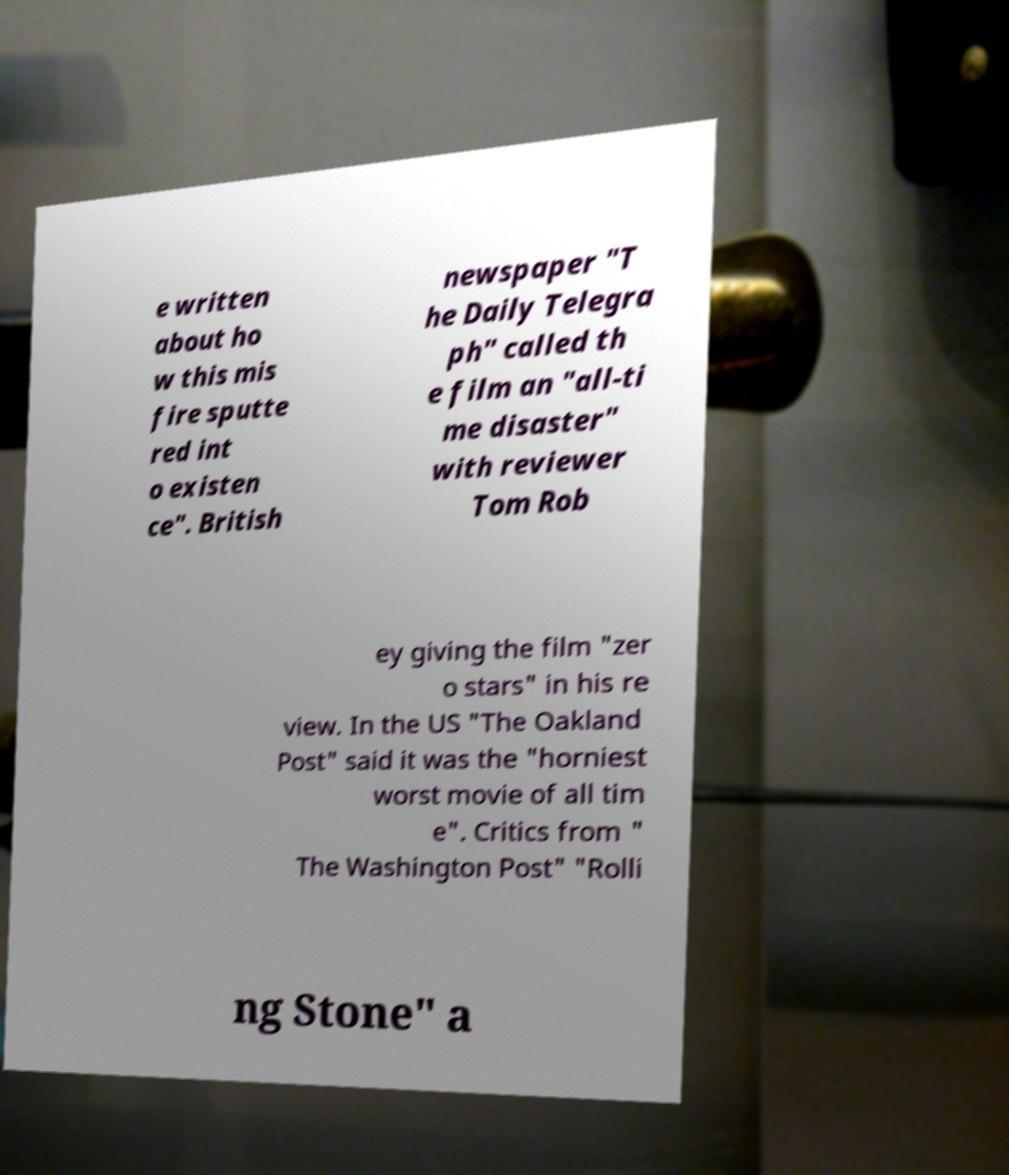Can you accurately transcribe the text from the provided image for me? e written about ho w this mis fire sputte red int o existen ce". British newspaper "T he Daily Telegra ph" called th e film an "all-ti me disaster" with reviewer Tom Rob ey giving the film "zer o stars" in his re view. In the US "The Oakland Post" said it was the "horniest worst movie of all tim e". Critics from " The Washington Post" "Rolli ng Stone" a 